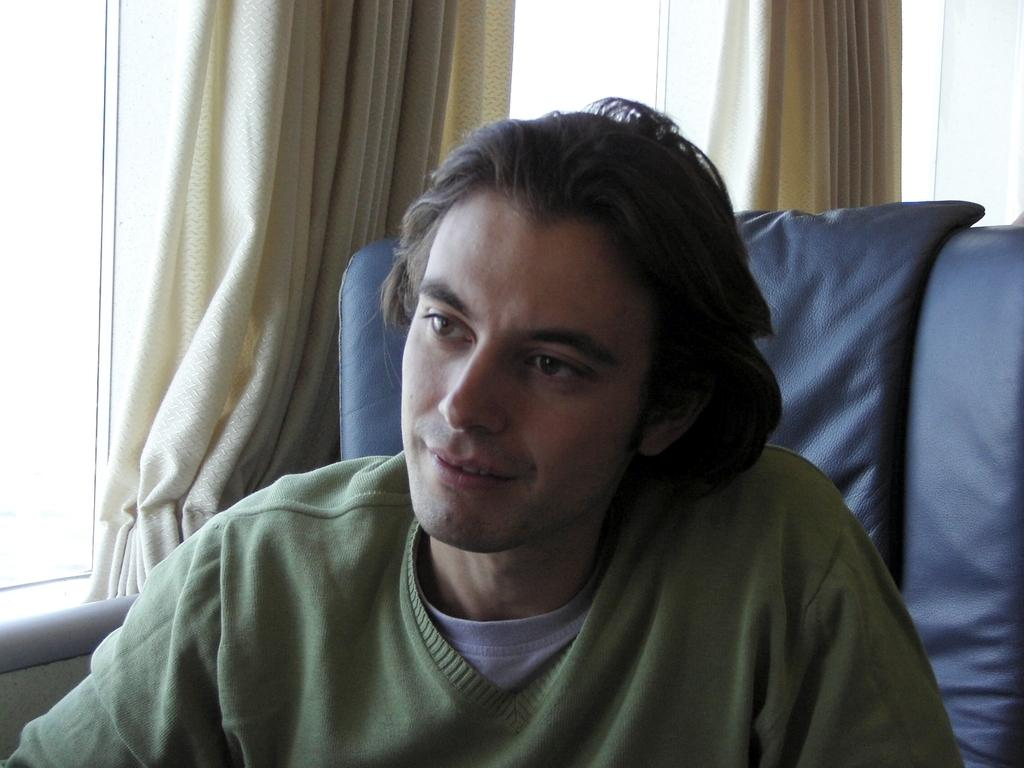What is the main subject of the image? There is a man in the image. What is the man wearing in the image? The man is wearing a sweater. What can be seen in the background of the image? There are curtains in the background of the image. What tax rate is applied to the man's sweater in the image? There is no information about tax rates in the image, as it only shows a man wearing a sweater and curtains in the background. 